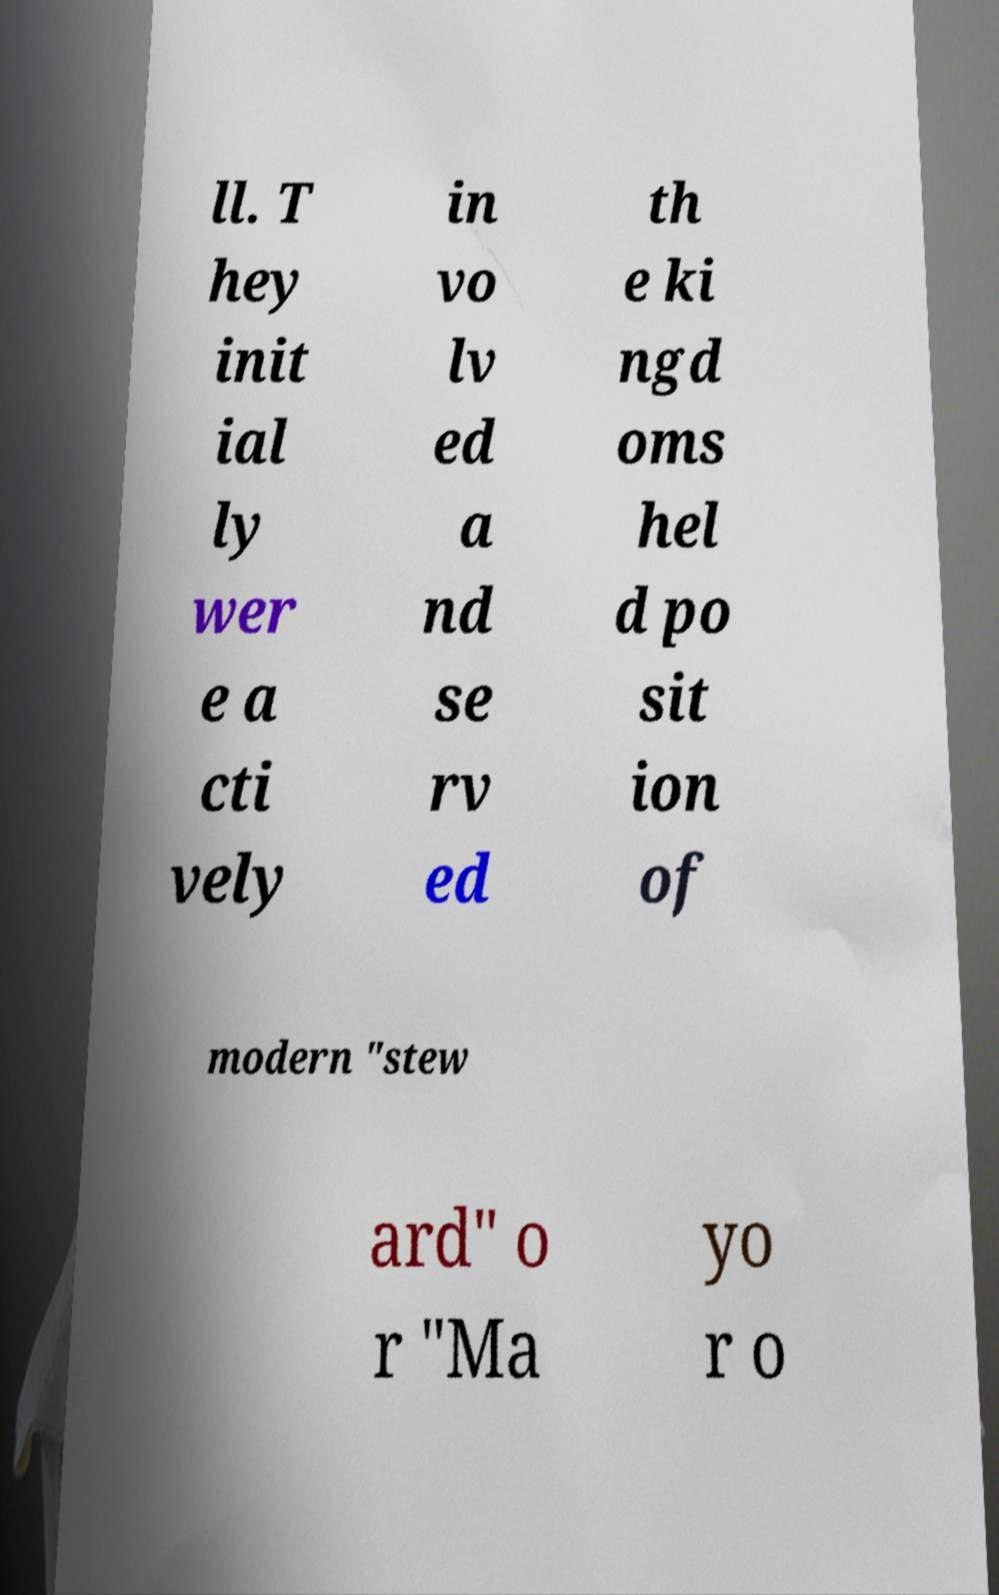For documentation purposes, I need the text within this image transcribed. Could you provide that? ll. T hey init ial ly wer e a cti vely in vo lv ed a nd se rv ed th e ki ngd oms hel d po sit ion of modern "stew ard" o r "Ma yo r o 